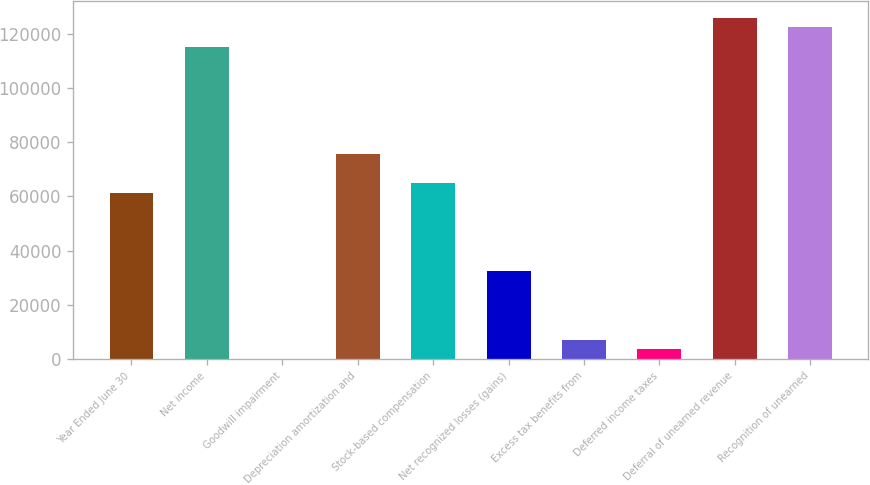Convert chart to OTSL. <chart><loc_0><loc_0><loc_500><loc_500><bar_chart><fcel>Year Ended June 30<fcel>Net income<fcel>Goodwill impairment<fcel>Depreciation amortization and<fcel>Stock-based compensation<fcel>Net recognized losses (gains)<fcel>Excess tax benefits from<fcel>Deferred income taxes<fcel>Deferral of unearned revenue<fcel>Recognition of unearned<nl><fcel>61188<fcel>115177<fcel>0.15<fcel>75585.1<fcel>64787.3<fcel>32393.7<fcel>7198.72<fcel>3599.43<fcel>125975<fcel>122376<nl></chart> 